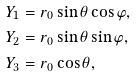Convert formula to latex. <formula><loc_0><loc_0><loc_500><loc_500>& Y _ { 1 } = r _ { 0 } \sin \theta \cos \varphi , \\ & Y _ { 2 } = r _ { 0 } \sin \theta \sin \varphi , \\ & Y _ { 3 } = r _ { 0 } \cos \theta ,</formula> 